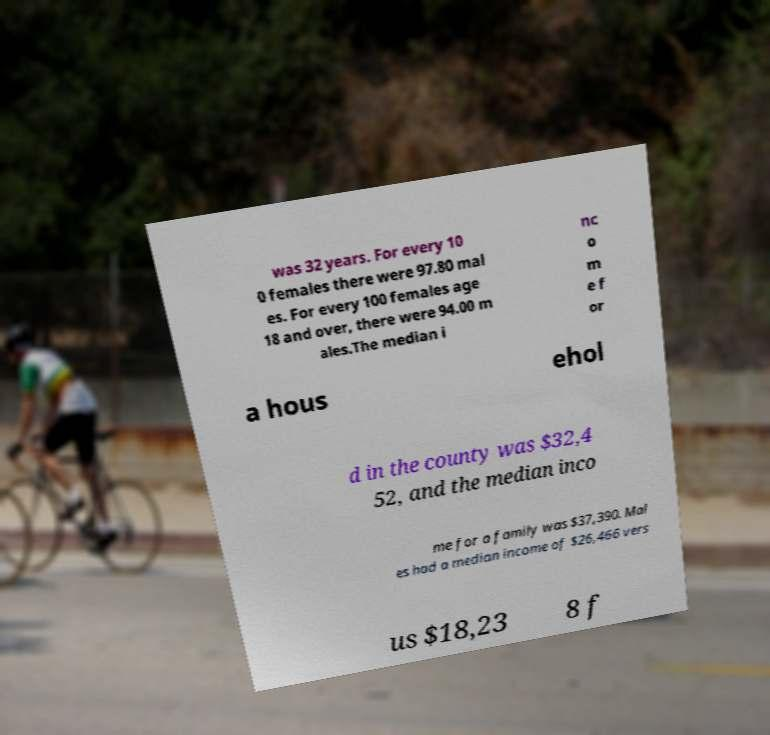Please identify and transcribe the text found in this image. was 32 years. For every 10 0 females there were 97.80 mal es. For every 100 females age 18 and over, there were 94.00 m ales.The median i nc o m e f or a hous ehol d in the county was $32,4 52, and the median inco me for a family was $37,390. Mal es had a median income of $26,466 vers us $18,23 8 f 